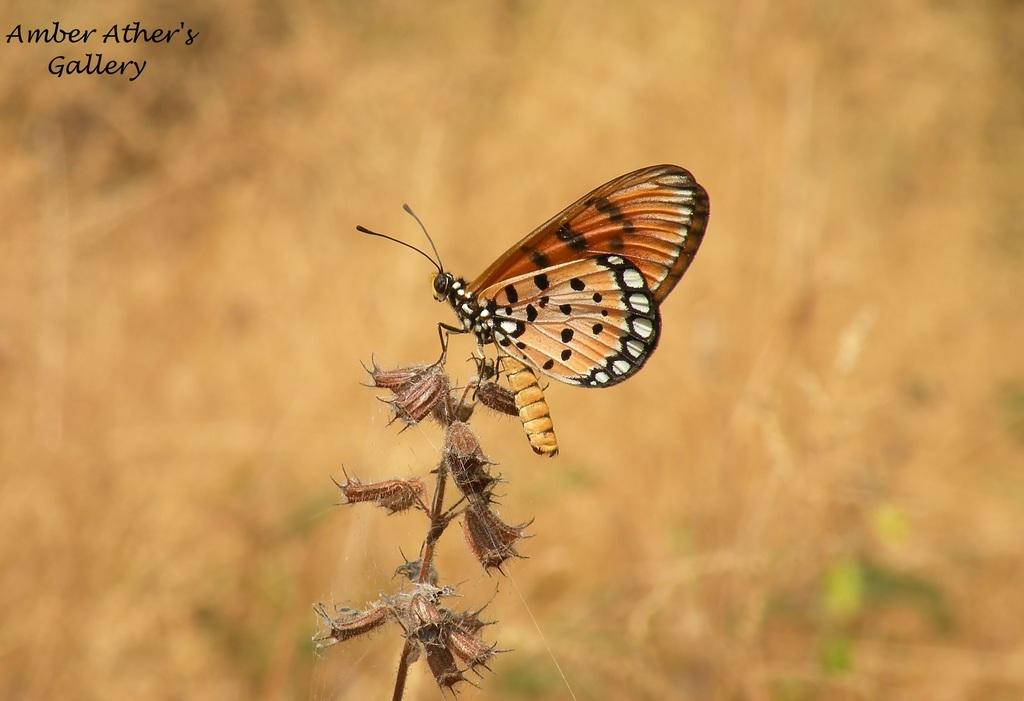What is the main subject of the image? There is a butterfly in the image. Where is the butterfly located? The butterfly is on a plant. Can you describe the background of the image? The background of the image is blurred. Is there any text present in the image? Yes, there is text written in the top left corner of the image. What type of treatment is being discussed by the committee in the image? There is no committee or discussion of treatment present in the image; it features a butterfly on a plant with a blurred background and text in the top left corner. Can you tell me how many pumps are visible in the image? There are no pumps visible in the image. 